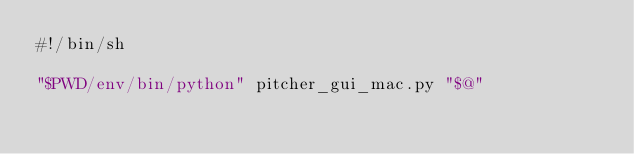Convert code to text. <code><loc_0><loc_0><loc_500><loc_500><_Bash_>#!/bin/sh

"$PWD/env/bin/python" pitcher_gui_mac.py "$@"
</code> 